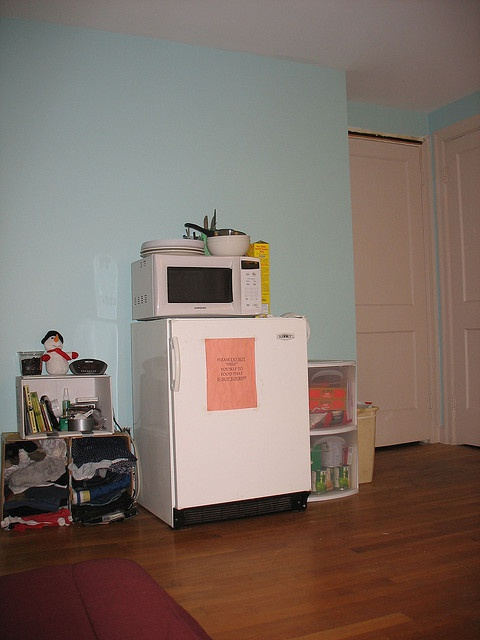Describe the objects in this image and their specific colors. I can see refrigerator in gray and lightgray tones, microwave in gray, darkgray, and black tones, bowl in gray and darkgray tones, book in gray, tan, black, olive, and maroon tones, and book in gray, olive, and black tones in this image. 